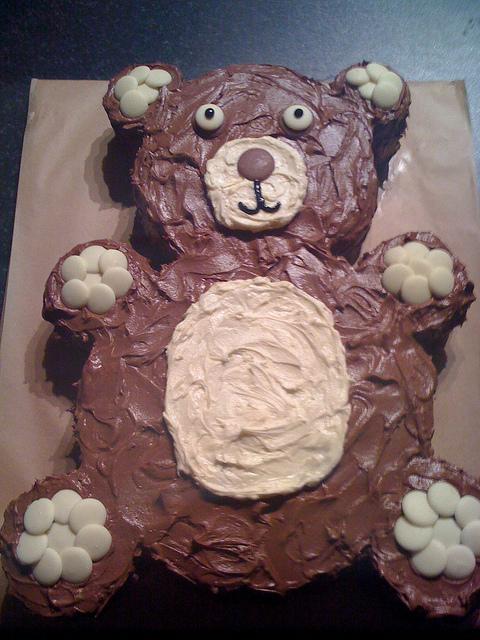How many round cakes did it take to make this bear?
Quick response, please. 8. Is the cake frosting brown?
Write a very short answer. Yes. Is this a sweet food?
Quick response, please. Yes. 